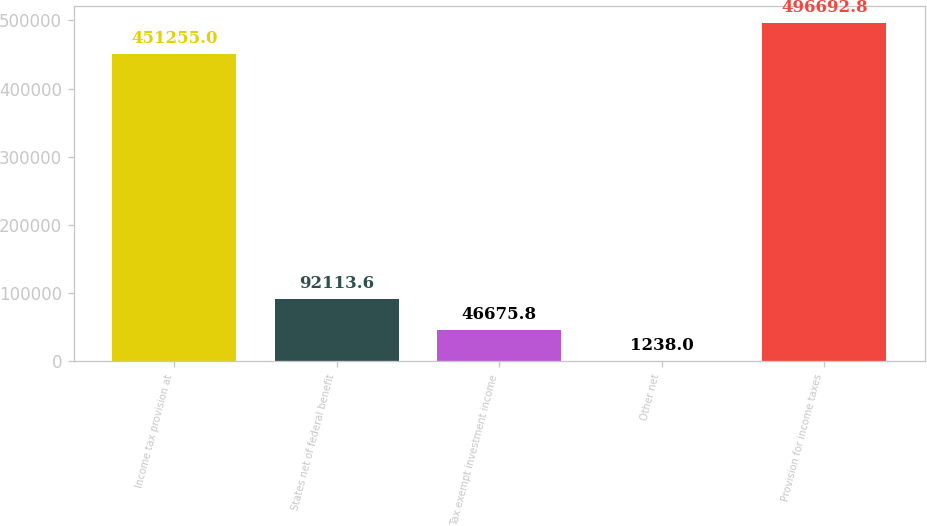Convert chart. <chart><loc_0><loc_0><loc_500><loc_500><bar_chart><fcel>Income tax provision at<fcel>States net of federal benefit<fcel>Tax exempt investment income<fcel>Other net<fcel>Provision for income taxes<nl><fcel>451255<fcel>92113.6<fcel>46675.8<fcel>1238<fcel>496693<nl></chart> 